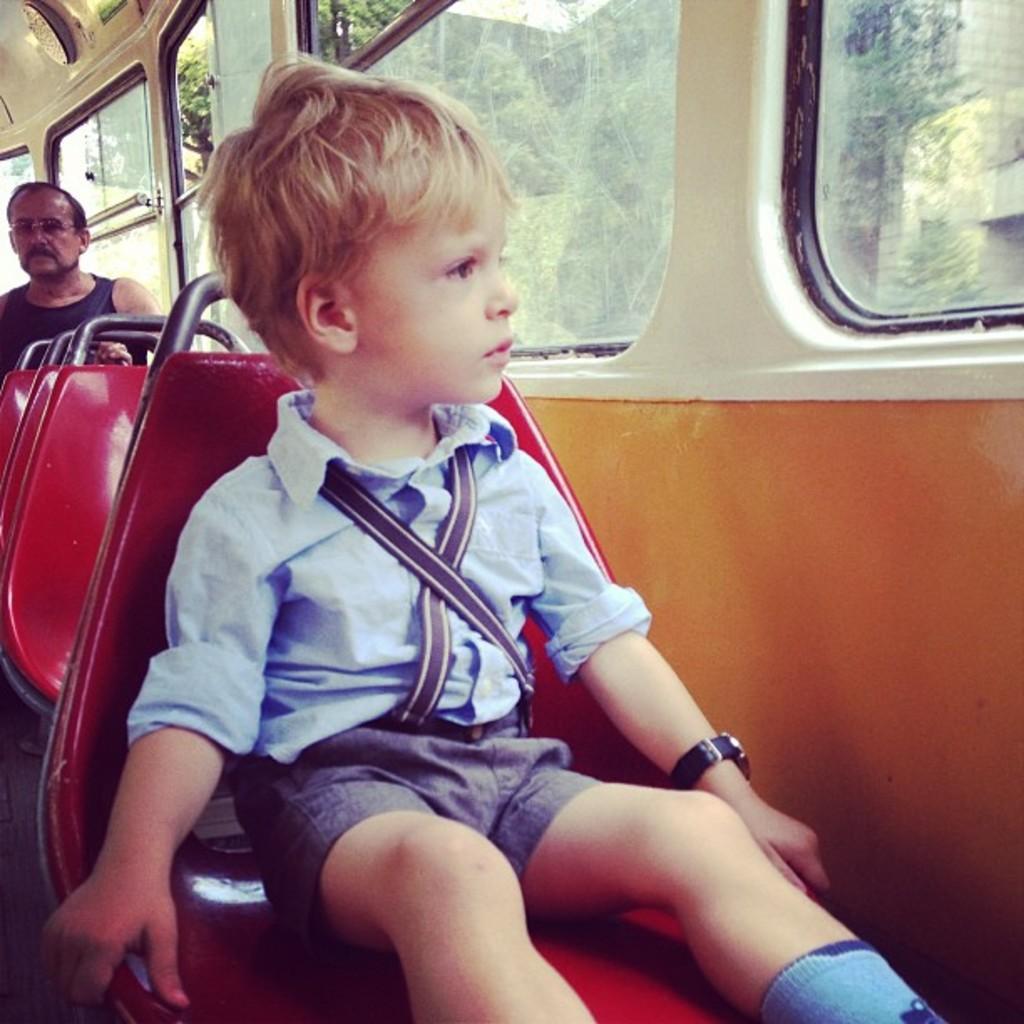Can you describe this image briefly? As we can see in the image there are two people sitting in bus and there are windows. Outside the windows there are trees and buildings. 